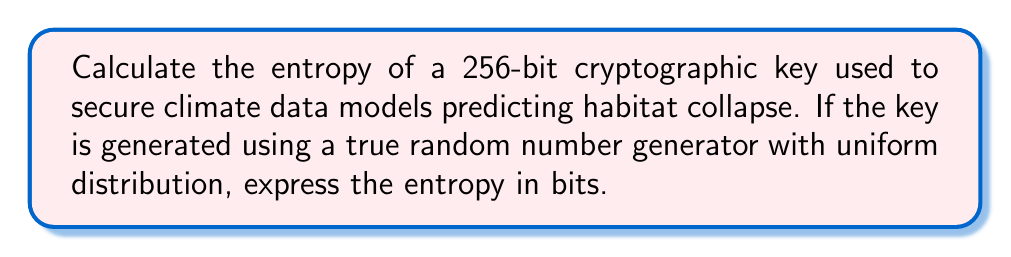Provide a solution to this math problem. To calculate the entropy of a cryptographic key, we need to follow these steps:

1. Understand the concept of entropy in cryptography:
   Entropy is a measure of randomness or unpredictability in a system. In cryptography, it represents the amount of information contained in a key.

2. Identify the key properties:
   - The key is 256 bits long
   - It is generated using a true random number generator
   - The distribution is uniform (all possible values are equally likely)

3. Apply the formula for entropy:
   For a uniformly distributed random variable, the entropy (H) is given by:
   
   $$ H = \log_2(N) $$
   
   Where N is the number of possible outcomes.

4. Calculate the number of possible outcomes:
   For a 256-bit key, there are $2^{256}$ possible combinations.

5. Substitute into the formula:
   $$ H = \log_2(2^{256}) $$

6. Simplify using the logarithm property $\log_a(a^n) = n$:
   $$ H = 256 $$

Therefore, the entropy of the 256-bit key is 256 bits.

This high entropy ensures that the climate data models predicting habitat collapse are secured with a cryptographic key that has maximum unpredictability, making it extremely difficult for unauthorized parties to guess or derive the key.
Answer: 256 bits 